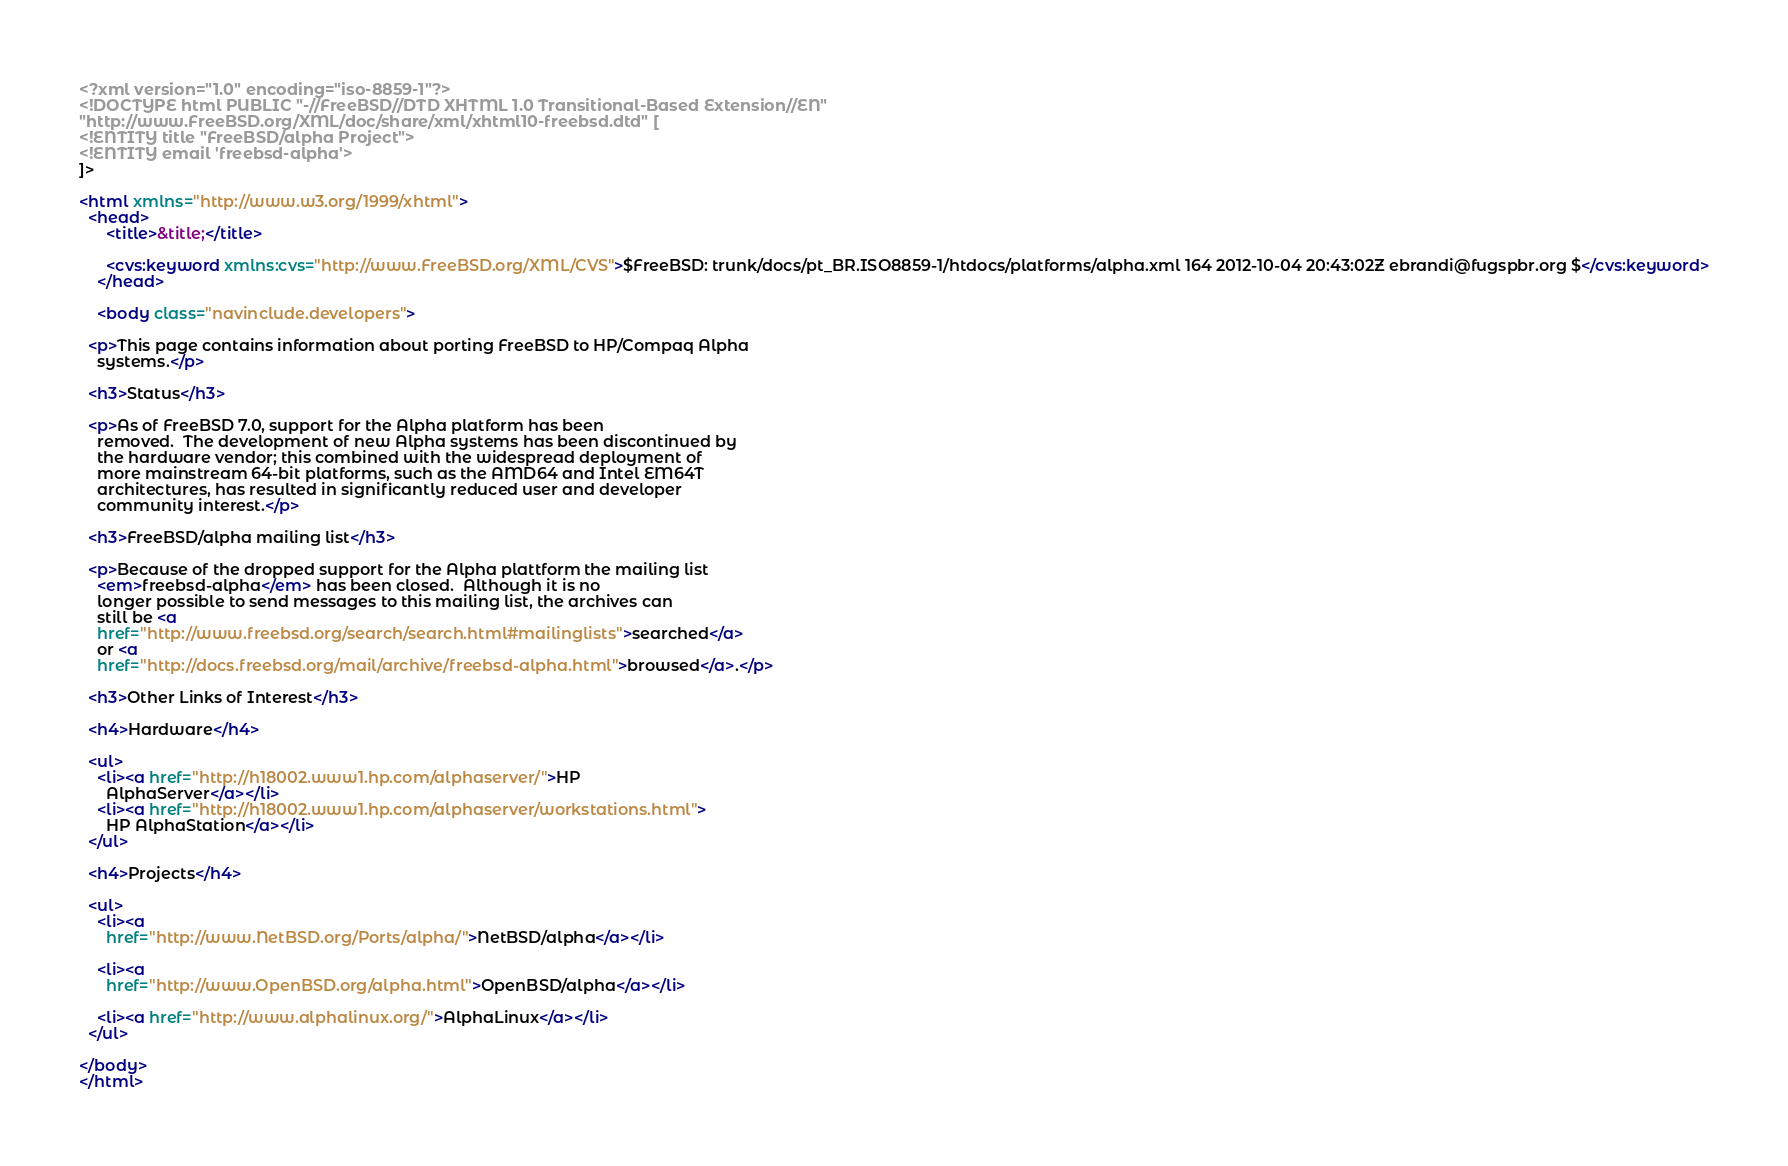<code> <loc_0><loc_0><loc_500><loc_500><_XML_><?xml version="1.0" encoding="iso-8859-1"?>
<!DOCTYPE html PUBLIC "-//FreeBSD//DTD XHTML 1.0 Transitional-Based Extension//EN"
"http://www.FreeBSD.org/XML/doc/share/xml/xhtml10-freebsd.dtd" [
<!ENTITY title "FreeBSD/alpha Project">
<!ENTITY email 'freebsd-alpha'>
]>

<html xmlns="http://www.w3.org/1999/xhtml">
  <head>
      <title>&title;</title>

      <cvs:keyword xmlns:cvs="http://www.FreeBSD.org/XML/CVS">$FreeBSD: trunk/docs/pt_BR.ISO8859-1/htdocs/platforms/alpha.xml 164 2012-10-04 20:43:02Z ebrandi@fugspbr.org $</cvs:keyword>
    </head>

    <body class="navinclude.developers">

  <p>This page contains information about porting FreeBSD to HP/Compaq Alpha
    systems.</p>

  <h3>Status</h3>

  <p>As of FreeBSD 7.0, support for the Alpha platform has been
    removed.  The development of new Alpha systems has been discontinued by
    the hardware vendor; this combined with the widespread deployment of
    more mainstream 64-bit platforms, such as the AMD64 and Intel EM64T
    architectures, has resulted in significantly reduced user and developer
    community interest.</p>

  <h3>FreeBSD/alpha mailing list</h3>

  <p>Because of the dropped support for the Alpha plattform the mailing list
    <em>freebsd-alpha</em> has been closed.  Although it is no
    longer possible to send messages to this mailing list, the archives can
    still be <a
    href="http://www.freebsd.org/search/search.html#mailinglists">searched</a>
    or <a
    href="http://docs.freebsd.org/mail/archive/freebsd-alpha.html">browsed</a>.</p>

  <h3>Other Links of Interest</h3>

  <h4>Hardware</h4>

  <ul>
    <li><a href="http://h18002.www1.hp.com/alphaserver/">HP
      AlphaServer</a></li>
    <li><a href="http://h18002.www1.hp.com/alphaserver/workstations.html">
      HP AlphaStation</a></li>
  </ul>

  <h4>Projects</h4>

  <ul>
    <li><a
      href="http://www.NetBSD.org/Ports/alpha/">NetBSD/alpha</a></li>

    <li><a
      href="http://www.OpenBSD.org/alpha.html">OpenBSD/alpha</a></li>

    <li><a href="http://www.alphalinux.org/">AlphaLinux</a></li>
  </ul>

</body>
</html>
</code> 